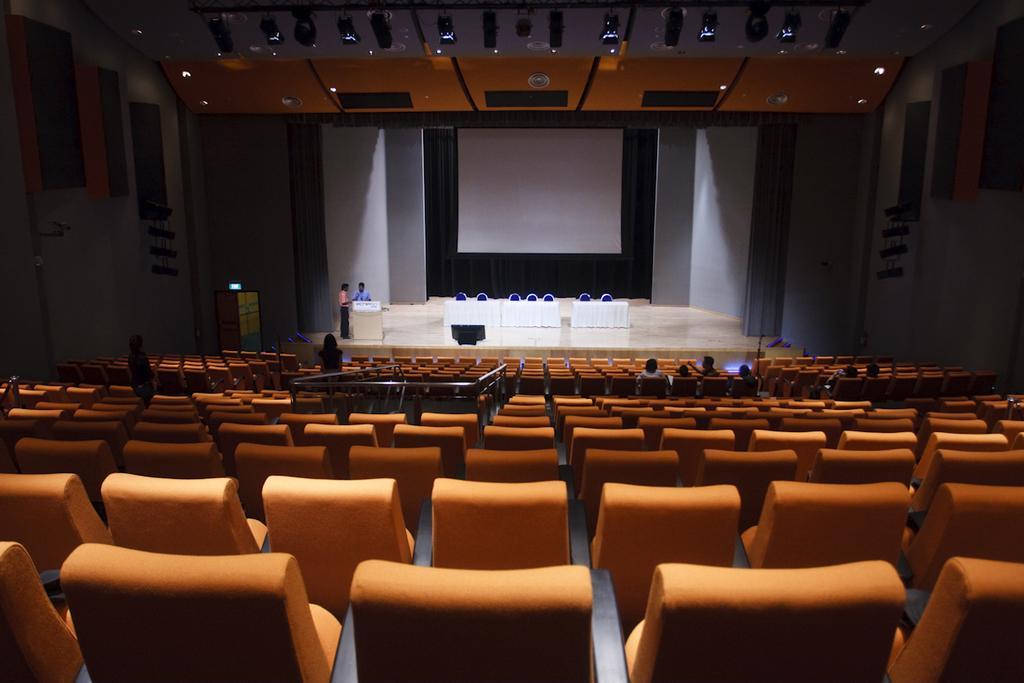Describe this image in one or two sentences. In the picture we can see an auditorium with number of chairs and in the background we can see a stage and on it we can see tables with a table cloths and behind it we can see some chairs and behind it we can see a screen to the wall and beside the table we can see a small desk with two persons standing near to it. 